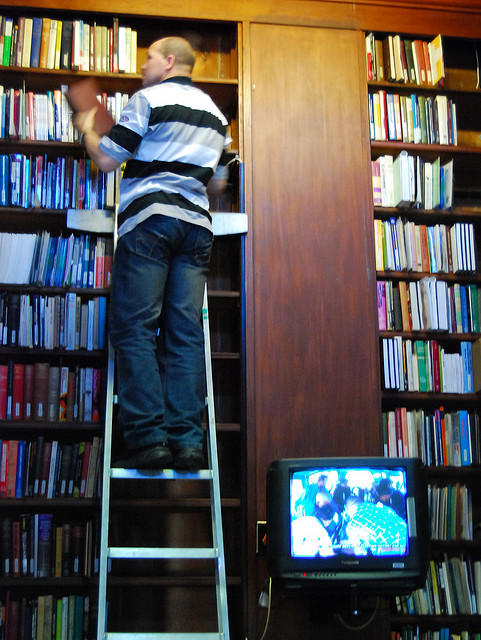How does the design of this library influence user interaction with the book collection? The design of this library, particularly its high shelving and the apparent lack of easily accessible tools like ladders or step stools, demands physical effort from its users, which could limit interactions for those with reduced mobility. By having essential readings placed on lower, more accessible shelves, or incorporating adjustable shelving systems, the library could promote a more inclusive environment. 